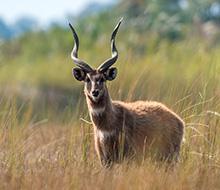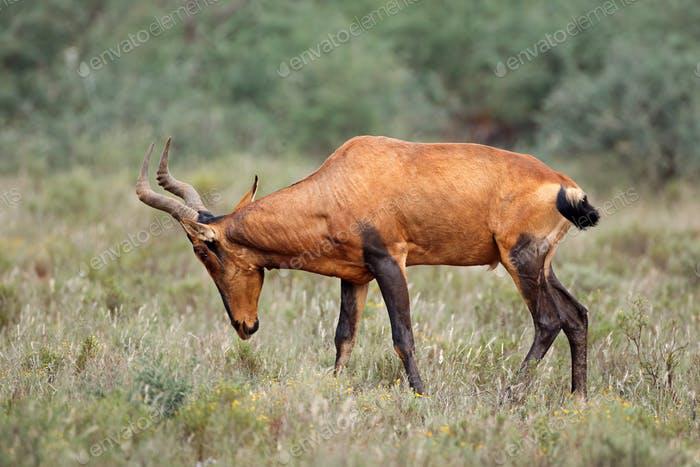The first image is the image on the left, the second image is the image on the right. Analyze the images presented: Is the assertion "The left and right image contains the same number of elk." valid? Answer yes or no. Yes. 